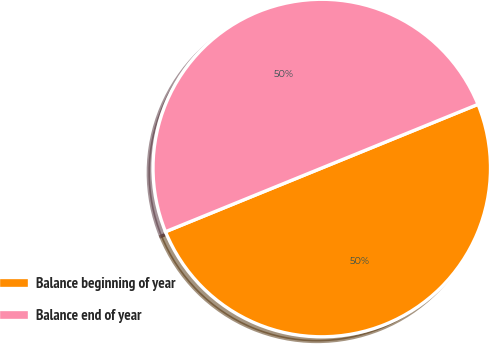Convert chart. <chart><loc_0><loc_0><loc_500><loc_500><pie_chart><fcel>Balance beginning of year<fcel>Balance end of year<nl><fcel>50.0%<fcel>50.0%<nl></chart> 